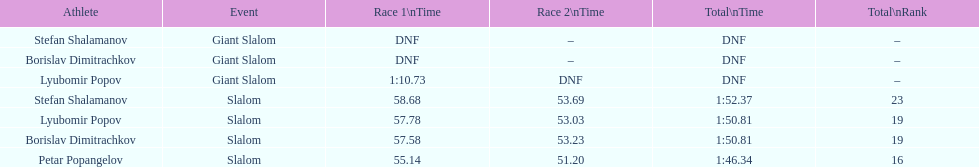What is the total number of athletes? 4. 